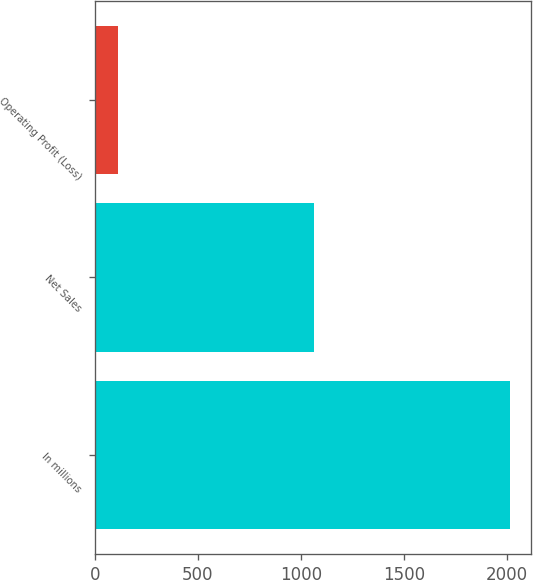<chart> <loc_0><loc_0><loc_500><loc_500><bar_chart><fcel>In millions<fcel>Net Sales<fcel>Operating Profit (Loss)<nl><fcel>2015<fcel>1064<fcel>111<nl></chart> 